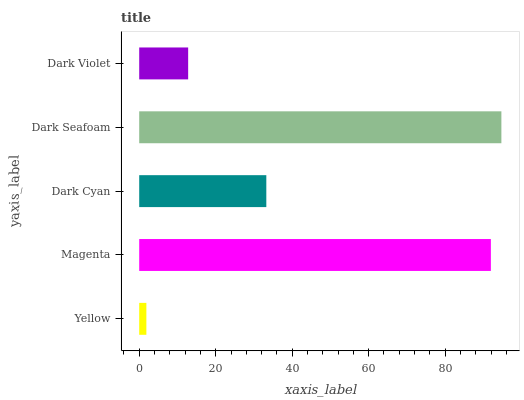Is Yellow the minimum?
Answer yes or no. Yes. Is Dark Seafoam the maximum?
Answer yes or no. Yes. Is Magenta the minimum?
Answer yes or no. No. Is Magenta the maximum?
Answer yes or no. No. Is Magenta greater than Yellow?
Answer yes or no. Yes. Is Yellow less than Magenta?
Answer yes or no. Yes. Is Yellow greater than Magenta?
Answer yes or no. No. Is Magenta less than Yellow?
Answer yes or no. No. Is Dark Cyan the high median?
Answer yes or no. Yes. Is Dark Cyan the low median?
Answer yes or no. Yes. Is Dark Seafoam the high median?
Answer yes or no. No. Is Dark Violet the low median?
Answer yes or no. No. 